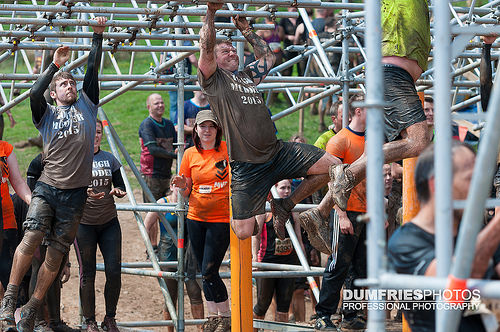<image>
Can you confirm if the man is under the obstacle course? Yes. The man is positioned underneath the obstacle course, with the obstacle course above it in the vertical space. Is the woman behind the pole? Yes. From this viewpoint, the woman is positioned behind the pole, with the pole partially or fully occluding the woman. 